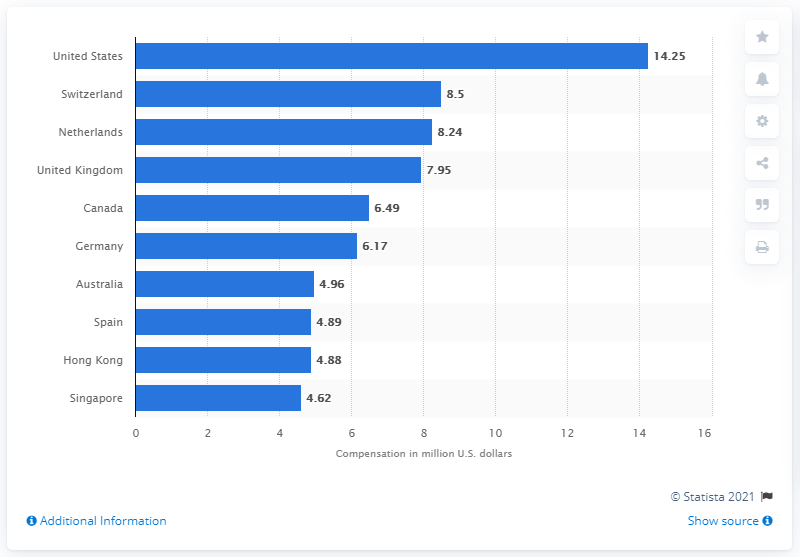Outline some significant characteristics in this image. In 2017, the average annual income of CEOs in the United States was 4.96 million dollars. In 2017, the average annual income of CEOs in the United States was 14.25. 